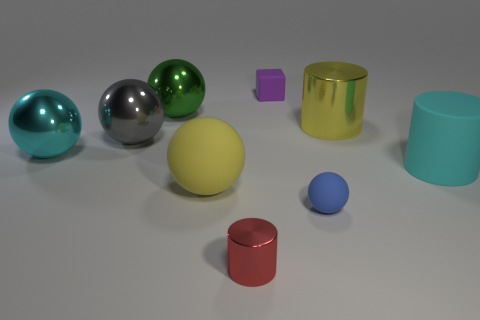Subtract all gray spheres. How many spheres are left? 4 Subtract all big cylinders. How many cylinders are left? 1 Add 1 red cubes. How many objects exist? 10 Subtract all green spheres. Subtract all yellow cylinders. How many spheres are left? 4 Subtract all cylinders. How many objects are left? 6 Add 7 cubes. How many cubes exist? 8 Subtract 1 red cylinders. How many objects are left? 8 Subtract all green things. Subtract all green balls. How many objects are left? 7 Add 4 large cyan cylinders. How many large cyan cylinders are left? 5 